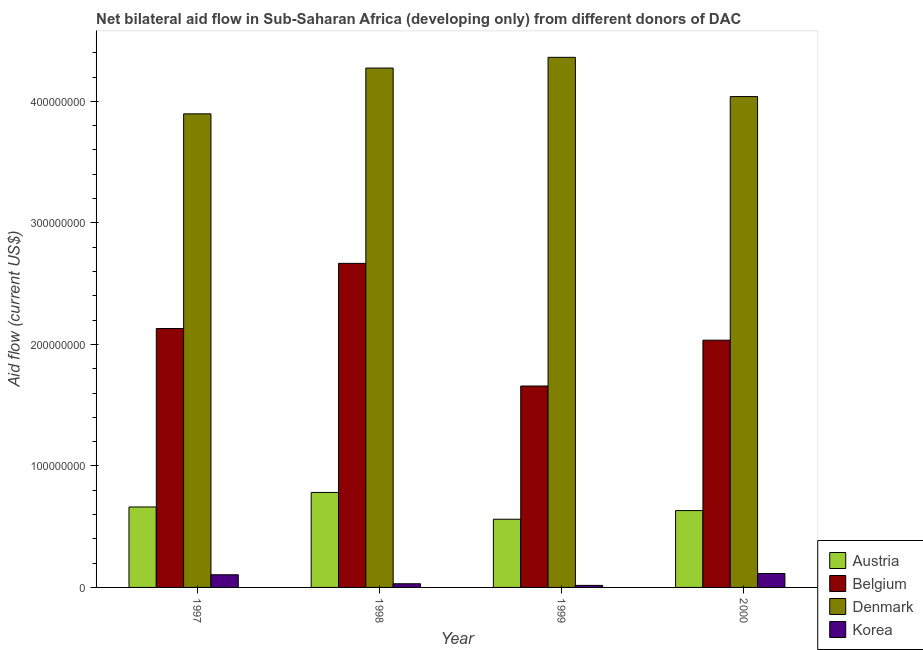Are the number of bars on each tick of the X-axis equal?
Offer a terse response. Yes. How many bars are there on the 4th tick from the left?
Ensure brevity in your answer.  4. How many bars are there on the 3rd tick from the right?
Your answer should be compact. 4. What is the amount of aid given by korea in 1997?
Offer a terse response. 1.04e+07. Across all years, what is the maximum amount of aid given by korea?
Offer a terse response. 1.14e+07. Across all years, what is the minimum amount of aid given by austria?
Your answer should be very brief. 5.61e+07. In which year was the amount of aid given by denmark minimum?
Make the answer very short. 1997. What is the total amount of aid given by korea in the graph?
Provide a short and direct response. 2.66e+07. What is the difference between the amount of aid given by korea in 1999 and that in 2000?
Ensure brevity in your answer.  -9.78e+06. What is the difference between the amount of aid given by belgium in 1998 and the amount of aid given by austria in 2000?
Your answer should be very brief. 6.32e+07. What is the average amount of aid given by austria per year?
Provide a succinct answer. 6.59e+07. In how many years, is the amount of aid given by belgium greater than 60000000 US$?
Make the answer very short. 4. What is the ratio of the amount of aid given by denmark in 1999 to that in 2000?
Give a very brief answer. 1.08. Is the difference between the amount of aid given by korea in 1998 and 1999 greater than the difference between the amount of aid given by belgium in 1998 and 1999?
Provide a succinct answer. No. What is the difference between the highest and the second highest amount of aid given by belgium?
Offer a very short reply. 5.36e+07. What is the difference between the highest and the lowest amount of aid given by korea?
Offer a terse response. 9.78e+06. In how many years, is the amount of aid given by belgium greater than the average amount of aid given by belgium taken over all years?
Your answer should be compact. 2. Is it the case that in every year, the sum of the amount of aid given by austria and amount of aid given by denmark is greater than the sum of amount of aid given by korea and amount of aid given by belgium?
Your response must be concise. Yes. What does the 3rd bar from the left in 1998 represents?
Make the answer very short. Denmark. What does the 1st bar from the right in 1997 represents?
Provide a short and direct response. Korea. How many bars are there?
Keep it short and to the point. 16. What is the difference between two consecutive major ticks on the Y-axis?
Your answer should be very brief. 1.00e+08. Are the values on the major ticks of Y-axis written in scientific E-notation?
Provide a short and direct response. No. Where does the legend appear in the graph?
Give a very brief answer. Bottom right. How are the legend labels stacked?
Your response must be concise. Vertical. What is the title of the graph?
Ensure brevity in your answer.  Net bilateral aid flow in Sub-Saharan Africa (developing only) from different donors of DAC. Does "Argument" appear as one of the legend labels in the graph?
Offer a terse response. No. What is the label or title of the X-axis?
Give a very brief answer. Year. What is the Aid flow (current US$) in Austria in 1997?
Give a very brief answer. 6.62e+07. What is the Aid flow (current US$) of Belgium in 1997?
Give a very brief answer. 2.13e+08. What is the Aid flow (current US$) in Denmark in 1997?
Your response must be concise. 3.90e+08. What is the Aid flow (current US$) in Korea in 1997?
Make the answer very short. 1.04e+07. What is the Aid flow (current US$) in Austria in 1998?
Your response must be concise. 7.82e+07. What is the Aid flow (current US$) in Belgium in 1998?
Keep it short and to the point. 2.67e+08. What is the Aid flow (current US$) of Denmark in 1998?
Offer a very short reply. 4.27e+08. What is the Aid flow (current US$) in Korea in 1998?
Make the answer very short. 3.02e+06. What is the Aid flow (current US$) in Austria in 1999?
Your response must be concise. 5.61e+07. What is the Aid flow (current US$) in Belgium in 1999?
Keep it short and to the point. 1.66e+08. What is the Aid flow (current US$) in Denmark in 1999?
Give a very brief answer. 4.36e+08. What is the Aid flow (current US$) in Korea in 1999?
Give a very brief answer. 1.67e+06. What is the Aid flow (current US$) of Austria in 2000?
Give a very brief answer. 6.32e+07. What is the Aid flow (current US$) in Belgium in 2000?
Offer a very short reply. 2.03e+08. What is the Aid flow (current US$) in Denmark in 2000?
Your response must be concise. 4.04e+08. What is the Aid flow (current US$) in Korea in 2000?
Offer a terse response. 1.14e+07. Across all years, what is the maximum Aid flow (current US$) in Austria?
Keep it short and to the point. 7.82e+07. Across all years, what is the maximum Aid flow (current US$) in Belgium?
Ensure brevity in your answer.  2.67e+08. Across all years, what is the maximum Aid flow (current US$) in Denmark?
Offer a terse response. 4.36e+08. Across all years, what is the maximum Aid flow (current US$) in Korea?
Offer a very short reply. 1.14e+07. Across all years, what is the minimum Aid flow (current US$) in Austria?
Give a very brief answer. 5.61e+07. Across all years, what is the minimum Aid flow (current US$) in Belgium?
Give a very brief answer. 1.66e+08. Across all years, what is the minimum Aid flow (current US$) of Denmark?
Give a very brief answer. 3.90e+08. Across all years, what is the minimum Aid flow (current US$) in Korea?
Your answer should be very brief. 1.67e+06. What is the total Aid flow (current US$) in Austria in the graph?
Ensure brevity in your answer.  2.64e+08. What is the total Aid flow (current US$) of Belgium in the graph?
Give a very brief answer. 8.49e+08. What is the total Aid flow (current US$) of Denmark in the graph?
Give a very brief answer. 1.66e+09. What is the total Aid flow (current US$) in Korea in the graph?
Your response must be concise. 2.66e+07. What is the difference between the Aid flow (current US$) in Austria in 1997 and that in 1998?
Provide a short and direct response. -1.20e+07. What is the difference between the Aid flow (current US$) of Belgium in 1997 and that in 1998?
Make the answer very short. -5.36e+07. What is the difference between the Aid flow (current US$) of Denmark in 1997 and that in 1998?
Your answer should be very brief. -3.77e+07. What is the difference between the Aid flow (current US$) of Korea in 1997 and that in 1998?
Make the answer very short. 7.39e+06. What is the difference between the Aid flow (current US$) of Austria in 1997 and that in 1999?
Your response must be concise. 1.01e+07. What is the difference between the Aid flow (current US$) of Belgium in 1997 and that in 1999?
Provide a short and direct response. 4.73e+07. What is the difference between the Aid flow (current US$) of Denmark in 1997 and that in 1999?
Offer a very short reply. -4.65e+07. What is the difference between the Aid flow (current US$) of Korea in 1997 and that in 1999?
Ensure brevity in your answer.  8.74e+06. What is the difference between the Aid flow (current US$) of Austria in 1997 and that in 2000?
Your answer should be very brief. 2.97e+06. What is the difference between the Aid flow (current US$) in Belgium in 1997 and that in 2000?
Provide a short and direct response. 9.61e+06. What is the difference between the Aid flow (current US$) in Denmark in 1997 and that in 2000?
Your answer should be very brief. -1.42e+07. What is the difference between the Aid flow (current US$) in Korea in 1997 and that in 2000?
Keep it short and to the point. -1.04e+06. What is the difference between the Aid flow (current US$) of Austria in 1998 and that in 1999?
Give a very brief answer. 2.20e+07. What is the difference between the Aid flow (current US$) in Belgium in 1998 and that in 1999?
Provide a succinct answer. 1.01e+08. What is the difference between the Aid flow (current US$) in Denmark in 1998 and that in 1999?
Provide a succinct answer. -8.83e+06. What is the difference between the Aid flow (current US$) in Korea in 1998 and that in 1999?
Offer a terse response. 1.35e+06. What is the difference between the Aid flow (current US$) in Austria in 1998 and that in 2000?
Your response must be concise. 1.49e+07. What is the difference between the Aid flow (current US$) of Belgium in 1998 and that in 2000?
Keep it short and to the point. 6.32e+07. What is the difference between the Aid flow (current US$) of Denmark in 1998 and that in 2000?
Ensure brevity in your answer.  2.35e+07. What is the difference between the Aid flow (current US$) in Korea in 1998 and that in 2000?
Your answer should be compact. -8.43e+06. What is the difference between the Aid flow (current US$) of Austria in 1999 and that in 2000?
Give a very brief answer. -7.12e+06. What is the difference between the Aid flow (current US$) in Belgium in 1999 and that in 2000?
Offer a very short reply. -3.77e+07. What is the difference between the Aid flow (current US$) of Denmark in 1999 and that in 2000?
Keep it short and to the point. 3.23e+07. What is the difference between the Aid flow (current US$) in Korea in 1999 and that in 2000?
Offer a terse response. -9.78e+06. What is the difference between the Aid flow (current US$) of Austria in 1997 and the Aid flow (current US$) of Belgium in 1998?
Your answer should be compact. -2.00e+08. What is the difference between the Aid flow (current US$) in Austria in 1997 and the Aid flow (current US$) in Denmark in 1998?
Offer a very short reply. -3.61e+08. What is the difference between the Aid flow (current US$) in Austria in 1997 and the Aid flow (current US$) in Korea in 1998?
Your answer should be very brief. 6.32e+07. What is the difference between the Aid flow (current US$) in Belgium in 1997 and the Aid flow (current US$) in Denmark in 1998?
Give a very brief answer. -2.14e+08. What is the difference between the Aid flow (current US$) of Belgium in 1997 and the Aid flow (current US$) of Korea in 1998?
Provide a succinct answer. 2.10e+08. What is the difference between the Aid flow (current US$) in Denmark in 1997 and the Aid flow (current US$) in Korea in 1998?
Give a very brief answer. 3.87e+08. What is the difference between the Aid flow (current US$) of Austria in 1997 and the Aid flow (current US$) of Belgium in 1999?
Your response must be concise. -9.95e+07. What is the difference between the Aid flow (current US$) in Austria in 1997 and the Aid flow (current US$) in Denmark in 1999?
Provide a short and direct response. -3.70e+08. What is the difference between the Aid flow (current US$) of Austria in 1997 and the Aid flow (current US$) of Korea in 1999?
Your response must be concise. 6.45e+07. What is the difference between the Aid flow (current US$) in Belgium in 1997 and the Aid flow (current US$) in Denmark in 1999?
Offer a very short reply. -2.23e+08. What is the difference between the Aid flow (current US$) of Belgium in 1997 and the Aid flow (current US$) of Korea in 1999?
Your answer should be very brief. 2.11e+08. What is the difference between the Aid flow (current US$) of Denmark in 1997 and the Aid flow (current US$) of Korea in 1999?
Provide a short and direct response. 3.88e+08. What is the difference between the Aid flow (current US$) of Austria in 1997 and the Aid flow (current US$) of Belgium in 2000?
Your response must be concise. -1.37e+08. What is the difference between the Aid flow (current US$) in Austria in 1997 and the Aid flow (current US$) in Denmark in 2000?
Provide a short and direct response. -3.38e+08. What is the difference between the Aid flow (current US$) in Austria in 1997 and the Aid flow (current US$) in Korea in 2000?
Provide a succinct answer. 5.48e+07. What is the difference between the Aid flow (current US$) in Belgium in 1997 and the Aid flow (current US$) in Denmark in 2000?
Provide a short and direct response. -1.91e+08. What is the difference between the Aid flow (current US$) in Belgium in 1997 and the Aid flow (current US$) in Korea in 2000?
Give a very brief answer. 2.02e+08. What is the difference between the Aid flow (current US$) in Denmark in 1997 and the Aid flow (current US$) in Korea in 2000?
Offer a very short reply. 3.78e+08. What is the difference between the Aid flow (current US$) in Austria in 1998 and the Aid flow (current US$) in Belgium in 1999?
Ensure brevity in your answer.  -8.76e+07. What is the difference between the Aid flow (current US$) of Austria in 1998 and the Aid flow (current US$) of Denmark in 1999?
Offer a very short reply. -3.58e+08. What is the difference between the Aid flow (current US$) in Austria in 1998 and the Aid flow (current US$) in Korea in 1999?
Make the answer very short. 7.65e+07. What is the difference between the Aid flow (current US$) of Belgium in 1998 and the Aid flow (current US$) of Denmark in 1999?
Offer a very short reply. -1.70e+08. What is the difference between the Aid flow (current US$) of Belgium in 1998 and the Aid flow (current US$) of Korea in 1999?
Keep it short and to the point. 2.65e+08. What is the difference between the Aid flow (current US$) of Denmark in 1998 and the Aid flow (current US$) of Korea in 1999?
Your answer should be compact. 4.26e+08. What is the difference between the Aid flow (current US$) of Austria in 1998 and the Aid flow (current US$) of Belgium in 2000?
Provide a succinct answer. -1.25e+08. What is the difference between the Aid flow (current US$) of Austria in 1998 and the Aid flow (current US$) of Denmark in 2000?
Give a very brief answer. -3.26e+08. What is the difference between the Aid flow (current US$) in Austria in 1998 and the Aid flow (current US$) in Korea in 2000?
Keep it short and to the point. 6.67e+07. What is the difference between the Aid flow (current US$) in Belgium in 1998 and the Aid flow (current US$) in Denmark in 2000?
Offer a terse response. -1.37e+08. What is the difference between the Aid flow (current US$) in Belgium in 1998 and the Aid flow (current US$) in Korea in 2000?
Offer a terse response. 2.55e+08. What is the difference between the Aid flow (current US$) of Denmark in 1998 and the Aid flow (current US$) of Korea in 2000?
Provide a short and direct response. 4.16e+08. What is the difference between the Aid flow (current US$) of Austria in 1999 and the Aid flow (current US$) of Belgium in 2000?
Keep it short and to the point. -1.47e+08. What is the difference between the Aid flow (current US$) of Austria in 1999 and the Aid flow (current US$) of Denmark in 2000?
Make the answer very short. -3.48e+08. What is the difference between the Aid flow (current US$) of Austria in 1999 and the Aid flow (current US$) of Korea in 2000?
Your answer should be compact. 4.47e+07. What is the difference between the Aid flow (current US$) of Belgium in 1999 and the Aid flow (current US$) of Denmark in 2000?
Offer a very short reply. -2.38e+08. What is the difference between the Aid flow (current US$) of Belgium in 1999 and the Aid flow (current US$) of Korea in 2000?
Your answer should be compact. 1.54e+08. What is the difference between the Aid flow (current US$) in Denmark in 1999 and the Aid flow (current US$) in Korea in 2000?
Offer a terse response. 4.25e+08. What is the average Aid flow (current US$) in Austria per year?
Provide a succinct answer. 6.59e+07. What is the average Aid flow (current US$) in Belgium per year?
Offer a terse response. 2.12e+08. What is the average Aid flow (current US$) in Denmark per year?
Provide a succinct answer. 4.14e+08. What is the average Aid flow (current US$) of Korea per year?
Keep it short and to the point. 6.64e+06. In the year 1997, what is the difference between the Aid flow (current US$) of Austria and Aid flow (current US$) of Belgium?
Your response must be concise. -1.47e+08. In the year 1997, what is the difference between the Aid flow (current US$) of Austria and Aid flow (current US$) of Denmark?
Your answer should be compact. -3.24e+08. In the year 1997, what is the difference between the Aid flow (current US$) of Austria and Aid flow (current US$) of Korea?
Provide a succinct answer. 5.58e+07. In the year 1997, what is the difference between the Aid flow (current US$) in Belgium and Aid flow (current US$) in Denmark?
Ensure brevity in your answer.  -1.77e+08. In the year 1997, what is the difference between the Aid flow (current US$) of Belgium and Aid flow (current US$) of Korea?
Provide a short and direct response. 2.03e+08. In the year 1997, what is the difference between the Aid flow (current US$) of Denmark and Aid flow (current US$) of Korea?
Ensure brevity in your answer.  3.79e+08. In the year 1998, what is the difference between the Aid flow (current US$) of Austria and Aid flow (current US$) of Belgium?
Keep it short and to the point. -1.89e+08. In the year 1998, what is the difference between the Aid flow (current US$) in Austria and Aid flow (current US$) in Denmark?
Give a very brief answer. -3.49e+08. In the year 1998, what is the difference between the Aid flow (current US$) in Austria and Aid flow (current US$) in Korea?
Provide a succinct answer. 7.52e+07. In the year 1998, what is the difference between the Aid flow (current US$) in Belgium and Aid flow (current US$) in Denmark?
Make the answer very short. -1.61e+08. In the year 1998, what is the difference between the Aid flow (current US$) of Belgium and Aid flow (current US$) of Korea?
Offer a terse response. 2.64e+08. In the year 1998, what is the difference between the Aid flow (current US$) of Denmark and Aid flow (current US$) of Korea?
Offer a terse response. 4.24e+08. In the year 1999, what is the difference between the Aid flow (current US$) in Austria and Aid flow (current US$) in Belgium?
Provide a short and direct response. -1.10e+08. In the year 1999, what is the difference between the Aid flow (current US$) of Austria and Aid flow (current US$) of Denmark?
Give a very brief answer. -3.80e+08. In the year 1999, what is the difference between the Aid flow (current US$) of Austria and Aid flow (current US$) of Korea?
Provide a short and direct response. 5.44e+07. In the year 1999, what is the difference between the Aid flow (current US$) in Belgium and Aid flow (current US$) in Denmark?
Your answer should be very brief. -2.70e+08. In the year 1999, what is the difference between the Aid flow (current US$) of Belgium and Aid flow (current US$) of Korea?
Your response must be concise. 1.64e+08. In the year 1999, what is the difference between the Aid flow (current US$) in Denmark and Aid flow (current US$) in Korea?
Provide a short and direct response. 4.35e+08. In the year 2000, what is the difference between the Aid flow (current US$) in Austria and Aid flow (current US$) in Belgium?
Give a very brief answer. -1.40e+08. In the year 2000, what is the difference between the Aid flow (current US$) in Austria and Aid flow (current US$) in Denmark?
Your answer should be compact. -3.41e+08. In the year 2000, what is the difference between the Aid flow (current US$) of Austria and Aid flow (current US$) of Korea?
Give a very brief answer. 5.18e+07. In the year 2000, what is the difference between the Aid flow (current US$) in Belgium and Aid flow (current US$) in Denmark?
Provide a short and direct response. -2.00e+08. In the year 2000, what is the difference between the Aid flow (current US$) in Belgium and Aid flow (current US$) in Korea?
Give a very brief answer. 1.92e+08. In the year 2000, what is the difference between the Aid flow (current US$) in Denmark and Aid flow (current US$) in Korea?
Make the answer very short. 3.92e+08. What is the ratio of the Aid flow (current US$) in Austria in 1997 to that in 1998?
Your answer should be compact. 0.85. What is the ratio of the Aid flow (current US$) of Belgium in 1997 to that in 1998?
Provide a short and direct response. 0.8. What is the ratio of the Aid flow (current US$) in Denmark in 1997 to that in 1998?
Your answer should be very brief. 0.91. What is the ratio of the Aid flow (current US$) in Korea in 1997 to that in 1998?
Make the answer very short. 3.45. What is the ratio of the Aid flow (current US$) of Austria in 1997 to that in 1999?
Offer a very short reply. 1.18. What is the ratio of the Aid flow (current US$) of Belgium in 1997 to that in 1999?
Your answer should be very brief. 1.29. What is the ratio of the Aid flow (current US$) of Denmark in 1997 to that in 1999?
Provide a short and direct response. 0.89. What is the ratio of the Aid flow (current US$) of Korea in 1997 to that in 1999?
Provide a short and direct response. 6.23. What is the ratio of the Aid flow (current US$) in Austria in 1997 to that in 2000?
Provide a succinct answer. 1.05. What is the ratio of the Aid flow (current US$) of Belgium in 1997 to that in 2000?
Make the answer very short. 1.05. What is the ratio of the Aid flow (current US$) in Denmark in 1997 to that in 2000?
Your answer should be very brief. 0.96. What is the ratio of the Aid flow (current US$) of Korea in 1997 to that in 2000?
Keep it short and to the point. 0.91. What is the ratio of the Aid flow (current US$) in Austria in 1998 to that in 1999?
Your answer should be compact. 1.39. What is the ratio of the Aid flow (current US$) in Belgium in 1998 to that in 1999?
Your answer should be compact. 1.61. What is the ratio of the Aid flow (current US$) in Denmark in 1998 to that in 1999?
Ensure brevity in your answer.  0.98. What is the ratio of the Aid flow (current US$) in Korea in 1998 to that in 1999?
Ensure brevity in your answer.  1.81. What is the ratio of the Aid flow (current US$) of Austria in 1998 to that in 2000?
Offer a very short reply. 1.24. What is the ratio of the Aid flow (current US$) of Belgium in 1998 to that in 2000?
Offer a terse response. 1.31. What is the ratio of the Aid flow (current US$) in Denmark in 1998 to that in 2000?
Your response must be concise. 1.06. What is the ratio of the Aid flow (current US$) in Korea in 1998 to that in 2000?
Your answer should be compact. 0.26. What is the ratio of the Aid flow (current US$) of Austria in 1999 to that in 2000?
Your answer should be compact. 0.89. What is the ratio of the Aid flow (current US$) in Belgium in 1999 to that in 2000?
Your response must be concise. 0.81. What is the ratio of the Aid flow (current US$) of Denmark in 1999 to that in 2000?
Provide a short and direct response. 1.08. What is the ratio of the Aid flow (current US$) of Korea in 1999 to that in 2000?
Your answer should be compact. 0.15. What is the difference between the highest and the second highest Aid flow (current US$) of Austria?
Keep it short and to the point. 1.20e+07. What is the difference between the highest and the second highest Aid flow (current US$) of Belgium?
Your answer should be compact. 5.36e+07. What is the difference between the highest and the second highest Aid flow (current US$) in Denmark?
Provide a short and direct response. 8.83e+06. What is the difference between the highest and the second highest Aid flow (current US$) of Korea?
Provide a succinct answer. 1.04e+06. What is the difference between the highest and the lowest Aid flow (current US$) of Austria?
Give a very brief answer. 2.20e+07. What is the difference between the highest and the lowest Aid flow (current US$) in Belgium?
Provide a short and direct response. 1.01e+08. What is the difference between the highest and the lowest Aid flow (current US$) in Denmark?
Your answer should be very brief. 4.65e+07. What is the difference between the highest and the lowest Aid flow (current US$) in Korea?
Your answer should be compact. 9.78e+06. 